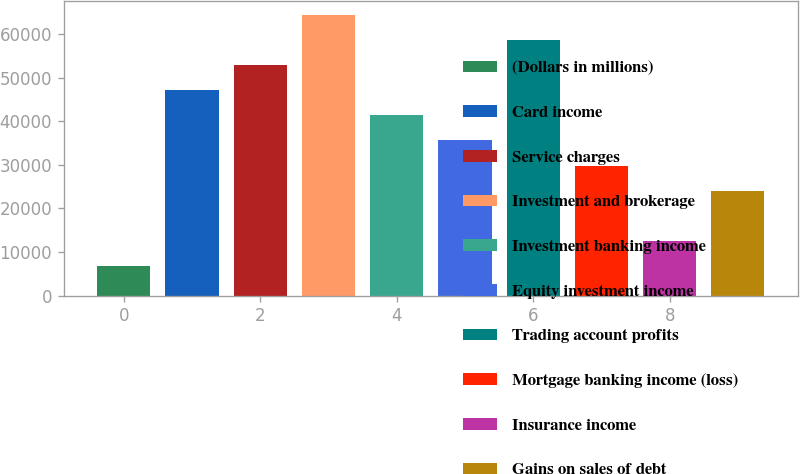Convert chart. <chart><loc_0><loc_0><loc_500><loc_500><bar_chart><fcel>(Dollars in millions)<fcel>Card income<fcel>Service charges<fcel>Investment and brokerage<fcel>Investment banking income<fcel>Equity investment income<fcel>Trading account profits<fcel>Mortgage banking income (loss)<fcel>Insurance income<fcel>Gains on sales of debt<nl><fcel>6740<fcel>47151<fcel>52924<fcel>64470<fcel>41378<fcel>35605<fcel>58697<fcel>29832<fcel>12513<fcel>24059<nl></chart> 